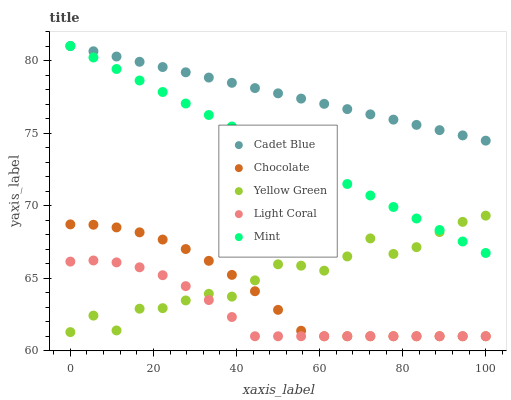Does Light Coral have the minimum area under the curve?
Answer yes or no. Yes. Does Cadet Blue have the maximum area under the curve?
Answer yes or no. Yes. Does Mint have the minimum area under the curve?
Answer yes or no. No. Does Mint have the maximum area under the curve?
Answer yes or no. No. Is Cadet Blue the smoothest?
Answer yes or no. Yes. Is Yellow Green the roughest?
Answer yes or no. Yes. Is Mint the smoothest?
Answer yes or no. No. Is Mint the roughest?
Answer yes or no. No. Does Light Coral have the lowest value?
Answer yes or no. Yes. Does Mint have the lowest value?
Answer yes or no. No. Does Mint have the highest value?
Answer yes or no. Yes. Does Yellow Green have the highest value?
Answer yes or no. No. Is Light Coral less than Mint?
Answer yes or no. Yes. Is Mint greater than Light Coral?
Answer yes or no. Yes. Does Yellow Green intersect Chocolate?
Answer yes or no. Yes. Is Yellow Green less than Chocolate?
Answer yes or no. No. Is Yellow Green greater than Chocolate?
Answer yes or no. No. Does Light Coral intersect Mint?
Answer yes or no. No. 